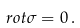Convert formula to latex. <formula><loc_0><loc_0><loc_500><loc_500>\ r o t \sigma = 0 \, .</formula> 